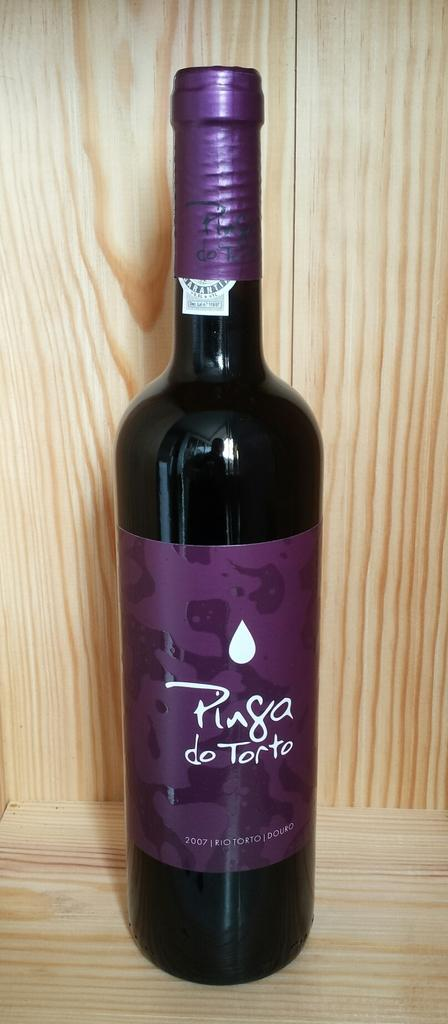<image>
Write a terse but informative summary of the picture. A dark colored glass bottle of Ping do Torto from 2007 with a purple label and white text. 